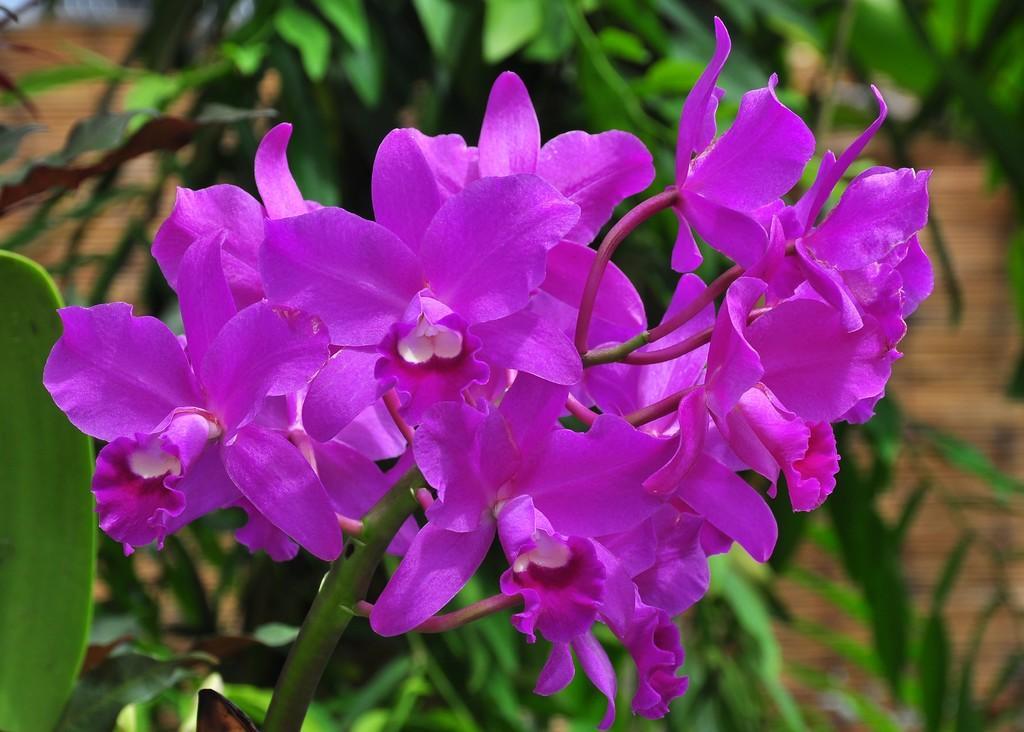In one or two sentences, can you explain what this image depicts? In this image I can see few flowers. In the background I can see trees. 